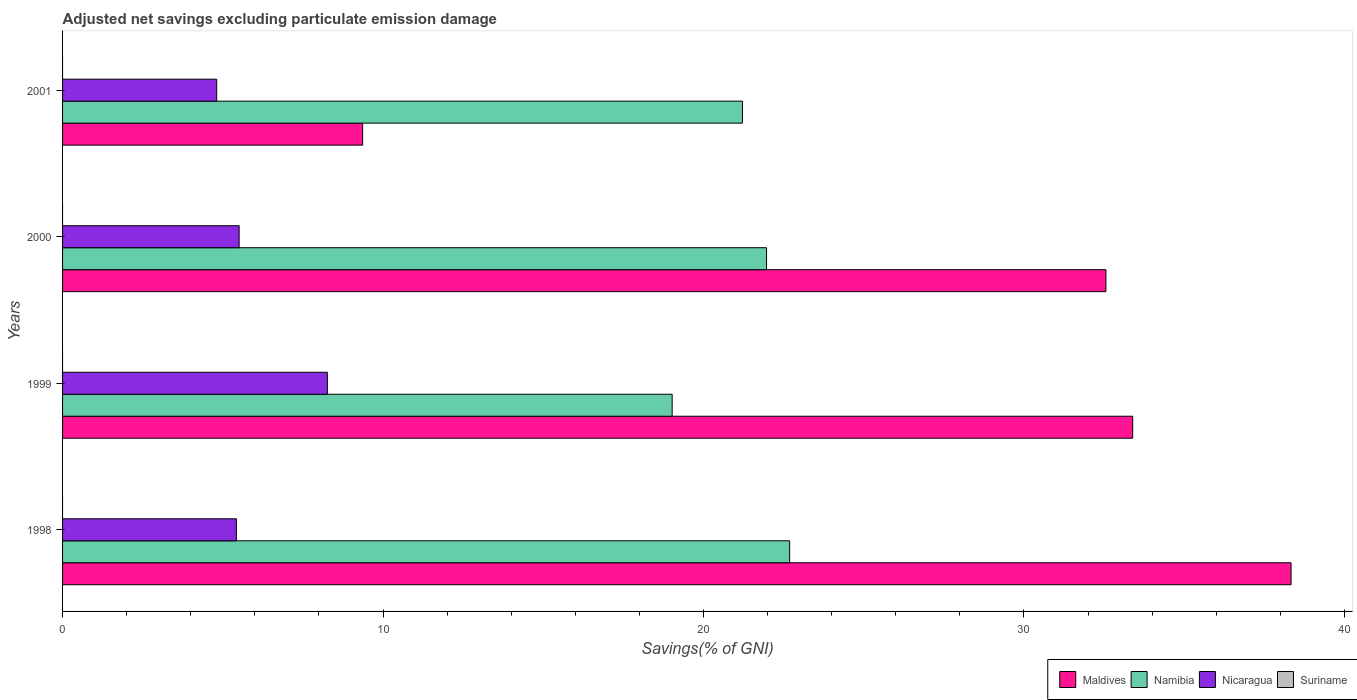How many different coloured bars are there?
Make the answer very short. 3. Are the number of bars per tick equal to the number of legend labels?
Offer a very short reply. No. How many bars are there on the 4th tick from the bottom?
Make the answer very short. 3. In how many cases, is the number of bars for a given year not equal to the number of legend labels?
Your answer should be very brief. 4. What is the adjusted net savings in Namibia in 2000?
Give a very brief answer. 21.97. Across all years, what is the maximum adjusted net savings in Namibia?
Make the answer very short. 22.69. Across all years, what is the minimum adjusted net savings in Maldives?
Provide a short and direct response. 9.36. What is the difference between the adjusted net savings in Namibia in 1999 and that in 2000?
Give a very brief answer. -2.95. What is the difference between the adjusted net savings in Nicaragua in 1998 and the adjusted net savings in Maldives in 1999?
Provide a short and direct response. -27.97. What is the average adjusted net savings in Suriname per year?
Your answer should be compact. 0. In the year 1999, what is the difference between the adjusted net savings in Nicaragua and adjusted net savings in Maldives?
Offer a very short reply. -25.13. In how many years, is the adjusted net savings in Nicaragua greater than 12 %?
Make the answer very short. 0. What is the ratio of the adjusted net savings in Nicaragua in 1998 to that in 1999?
Your response must be concise. 0.66. What is the difference between the highest and the second highest adjusted net savings in Nicaragua?
Your response must be concise. 2.75. What is the difference between the highest and the lowest adjusted net savings in Maldives?
Keep it short and to the point. 28.97. In how many years, is the adjusted net savings in Maldives greater than the average adjusted net savings in Maldives taken over all years?
Your response must be concise. 3. Is it the case that in every year, the sum of the adjusted net savings in Maldives and adjusted net savings in Suriname is greater than the sum of adjusted net savings in Nicaragua and adjusted net savings in Namibia?
Give a very brief answer. No. Is it the case that in every year, the sum of the adjusted net savings in Namibia and adjusted net savings in Suriname is greater than the adjusted net savings in Nicaragua?
Provide a succinct answer. Yes. Does the graph contain any zero values?
Your response must be concise. Yes. Does the graph contain grids?
Offer a very short reply. No. What is the title of the graph?
Offer a terse response. Adjusted net savings excluding particulate emission damage. Does "Israel" appear as one of the legend labels in the graph?
Offer a very short reply. No. What is the label or title of the X-axis?
Ensure brevity in your answer.  Savings(% of GNI). What is the label or title of the Y-axis?
Provide a short and direct response. Years. What is the Savings(% of GNI) in Maldives in 1998?
Offer a very short reply. 38.34. What is the Savings(% of GNI) in Namibia in 1998?
Make the answer very short. 22.69. What is the Savings(% of GNI) in Nicaragua in 1998?
Make the answer very short. 5.42. What is the Savings(% of GNI) in Maldives in 1999?
Provide a short and direct response. 33.4. What is the Savings(% of GNI) in Namibia in 1999?
Offer a terse response. 19.02. What is the Savings(% of GNI) in Nicaragua in 1999?
Provide a short and direct response. 8.26. What is the Savings(% of GNI) of Maldives in 2000?
Your answer should be compact. 32.56. What is the Savings(% of GNI) in Namibia in 2000?
Your response must be concise. 21.97. What is the Savings(% of GNI) in Nicaragua in 2000?
Make the answer very short. 5.51. What is the Savings(% of GNI) in Suriname in 2000?
Keep it short and to the point. 0. What is the Savings(% of GNI) of Maldives in 2001?
Provide a short and direct response. 9.36. What is the Savings(% of GNI) in Namibia in 2001?
Offer a very short reply. 21.22. What is the Savings(% of GNI) in Nicaragua in 2001?
Offer a terse response. 4.81. Across all years, what is the maximum Savings(% of GNI) in Maldives?
Offer a terse response. 38.34. Across all years, what is the maximum Savings(% of GNI) in Namibia?
Provide a succinct answer. 22.69. Across all years, what is the maximum Savings(% of GNI) in Nicaragua?
Provide a succinct answer. 8.26. Across all years, what is the minimum Savings(% of GNI) in Maldives?
Your answer should be very brief. 9.36. Across all years, what is the minimum Savings(% of GNI) in Namibia?
Provide a succinct answer. 19.02. Across all years, what is the minimum Savings(% of GNI) in Nicaragua?
Your answer should be compact. 4.81. What is the total Savings(% of GNI) in Maldives in the graph?
Provide a succinct answer. 113.66. What is the total Savings(% of GNI) in Namibia in the graph?
Keep it short and to the point. 84.9. What is the total Savings(% of GNI) of Nicaragua in the graph?
Your response must be concise. 24.01. What is the difference between the Savings(% of GNI) of Maldives in 1998 and that in 1999?
Your answer should be very brief. 4.94. What is the difference between the Savings(% of GNI) in Namibia in 1998 and that in 1999?
Your response must be concise. 3.67. What is the difference between the Savings(% of GNI) in Nicaragua in 1998 and that in 1999?
Your answer should be very brief. -2.84. What is the difference between the Savings(% of GNI) of Maldives in 1998 and that in 2000?
Offer a terse response. 5.78. What is the difference between the Savings(% of GNI) of Namibia in 1998 and that in 2000?
Make the answer very short. 0.72. What is the difference between the Savings(% of GNI) in Nicaragua in 1998 and that in 2000?
Your response must be concise. -0.09. What is the difference between the Savings(% of GNI) of Maldives in 1998 and that in 2001?
Provide a succinct answer. 28.97. What is the difference between the Savings(% of GNI) in Namibia in 1998 and that in 2001?
Keep it short and to the point. 1.47. What is the difference between the Savings(% of GNI) in Nicaragua in 1998 and that in 2001?
Your answer should be very brief. 0.61. What is the difference between the Savings(% of GNI) of Maldives in 1999 and that in 2000?
Your answer should be compact. 0.84. What is the difference between the Savings(% of GNI) of Namibia in 1999 and that in 2000?
Give a very brief answer. -2.95. What is the difference between the Savings(% of GNI) in Nicaragua in 1999 and that in 2000?
Make the answer very short. 2.75. What is the difference between the Savings(% of GNI) of Maldives in 1999 and that in 2001?
Provide a short and direct response. 24.03. What is the difference between the Savings(% of GNI) in Namibia in 1999 and that in 2001?
Keep it short and to the point. -2.19. What is the difference between the Savings(% of GNI) of Nicaragua in 1999 and that in 2001?
Provide a short and direct response. 3.45. What is the difference between the Savings(% of GNI) in Maldives in 2000 and that in 2001?
Offer a very short reply. 23.19. What is the difference between the Savings(% of GNI) in Namibia in 2000 and that in 2001?
Provide a succinct answer. 0.75. What is the difference between the Savings(% of GNI) in Nicaragua in 2000 and that in 2001?
Your response must be concise. 0.7. What is the difference between the Savings(% of GNI) of Maldives in 1998 and the Savings(% of GNI) of Namibia in 1999?
Ensure brevity in your answer.  19.31. What is the difference between the Savings(% of GNI) in Maldives in 1998 and the Savings(% of GNI) in Nicaragua in 1999?
Make the answer very short. 30.07. What is the difference between the Savings(% of GNI) of Namibia in 1998 and the Savings(% of GNI) of Nicaragua in 1999?
Provide a short and direct response. 14.43. What is the difference between the Savings(% of GNI) in Maldives in 1998 and the Savings(% of GNI) in Namibia in 2000?
Your answer should be compact. 16.37. What is the difference between the Savings(% of GNI) of Maldives in 1998 and the Savings(% of GNI) of Nicaragua in 2000?
Keep it short and to the point. 32.83. What is the difference between the Savings(% of GNI) of Namibia in 1998 and the Savings(% of GNI) of Nicaragua in 2000?
Offer a terse response. 17.18. What is the difference between the Savings(% of GNI) in Maldives in 1998 and the Savings(% of GNI) in Namibia in 2001?
Provide a succinct answer. 17.12. What is the difference between the Savings(% of GNI) in Maldives in 1998 and the Savings(% of GNI) in Nicaragua in 2001?
Offer a terse response. 33.53. What is the difference between the Savings(% of GNI) of Namibia in 1998 and the Savings(% of GNI) of Nicaragua in 2001?
Your answer should be compact. 17.88. What is the difference between the Savings(% of GNI) of Maldives in 1999 and the Savings(% of GNI) of Namibia in 2000?
Provide a succinct answer. 11.43. What is the difference between the Savings(% of GNI) in Maldives in 1999 and the Savings(% of GNI) in Nicaragua in 2000?
Offer a very short reply. 27.89. What is the difference between the Savings(% of GNI) of Namibia in 1999 and the Savings(% of GNI) of Nicaragua in 2000?
Provide a succinct answer. 13.51. What is the difference between the Savings(% of GNI) in Maldives in 1999 and the Savings(% of GNI) in Namibia in 2001?
Your answer should be very brief. 12.18. What is the difference between the Savings(% of GNI) of Maldives in 1999 and the Savings(% of GNI) of Nicaragua in 2001?
Give a very brief answer. 28.59. What is the difference between the Savings(% of GNI) in Namibia in 1999 and the Savings(% of GNI) in Nicaragua in 2001?
Your response must be concise. 14.21. What is the difference between the Savings(% of GNI) in Maldives in 2000 and the Savings(% of GNI) in Namibia in 2001?
Give a very brief answer. 11.34. What is the difference between the Savings(% of GNI) of Maldives in 2000 and the Savings(% of GNI) of Nicaragua in 2001?
Provide a short and direct response. 27.75. What is the difference between the Savings(% of GNI) of Namibia in 2000 and the Savings(% of GNI) of Nicaragua in 2001?
Make the answer very short. 17.16. What is the average Savings(% of GNI) of Maldives per year?
Your answer should be compact. 28.41. What is the average Savings(% of GNI) of Namibia per year?
Provide a succinct answer. 21.22. What is the average Savings(% of GNI) in Nicaragua per year?
Provide a succinct answer. 6. In the year 1998, what is the difference between the Savings(% of GNI) of Maldives and Savings(% of GNI) of Namibia?
Your response must be concise. 15.65. In the year 1998, what is the difference between the Savings(% of GNI) in Maldives and Savings(% of GNI) in Nicaragua?
Give a very brief answer. 32.91. In the year 1998, what is the difference between the Savings(% of GNI) of Namibia and Savings(% of GNI) of Nicaragua?
Ensure brevity in your answer.  17.27. In the year 1999, what is the difference between the Savings(% of GNI) in Maldives and Savings(% of GNI) in Namibia?
Provide a short and direct response. 14.37. In the year 1999, what is the difference between the Savings(% of GNI) in Maldives and Savings(% of GNI) in Nicaragua?
Your response must be concise. 25.13. In the year 1999, what is the difference between the Savings(% of GNI) in Namibia and Savings(% of GNI) in Nicaragua?
Offer a terse response. 10.76. In the year 2000, what is the difference between the Savings(% of GNI) of Maldives and Savings(% of GNI) of Namibia?
Provide a succinct answer. 10.59. In the year 2000, what is the difference between the Savings(% of GNI) in Maldives and Savings(% of GNI) in Nicaragua?
Your answer should be very brief. 27.05. In the year 2000, what is the difference between the Savings(% of GNI) in Namibia and Savings(% of GNI) in Nicaragua?
Make the answer very short. 16.46. In the year 2001, what is the difference between the Savings(% of GNI) in Maldives and Savings(% of GNI) in Namibia?
Make the answer very short. -11.85. In the year 2001, what is the difference between the Savings(% of GNI) in Maldives and Savings(% of GNI) in Nicaragua?
Your answer should be compact. 4.56. In the year 2001, what is the difference between the Savings(% of GNI) of Namibia and Savings(% of GNI) of Nicaragua?
Provide a short and direct response. 16.41. What is the ratio of the Savings(% of GNI) in Maldives in 1998 to that in 1999?
Your answer should be compact. 1.15. What is the ratio of the Savings(% of GNI) of Namibia in 1998 to that in 1999?
Give a very brief answer. 1.19. What is the ratio of the Savings(% of GNI) in Nicaragua in 1998 to that in 1999?
Your answer should be very brief. 0.66. What is the ratio of the Savings(% of GNI) of Maldives in 1998 to that in 2000?
Your answer should be very brief. 1.18. What is the ratio of the Savings(% of GNI) of Namibia in 1998 to that in 2000?
Provide a short and direct response. 1.03. What is the ratio of the Savings(% of GNI) in Nicaragua in 1998 to that in 2000?
Offer a terse response. 0.98. What is the ratio of the Savings(% of GNI) of Maldives in 1998 to that in 2001?
Your response must be concise. 4.09. What is the ratio of the Savings(% of GNI) in Namibia in 1998 to that in 2001?
Your answer should be compact. 1.07. What is the ratio of the Savings(% of GNI) of Nicaragua in 1998 to that in 2001?
Provide a short and direct response. 1.13. What is the ratio of the Savings(% of GNI) of Maldives in 1999 to that in 2000?
Your answer should be compact. 1.03. What is the ratio of the Savings(% of GNI) in Namibia in 1999 to that in 2000?
Keep it short and to the point. 0.87. What is the ratio of the Savings(% of GNI) in Nicaragua in 1999 to that in 2000?
Make the answer very short. 1.5. What is the ratio of the Savings(% of GNI) in Maldives in 1999 to that in 2001?
Ensure brevity in your answer.  3.57. What is the ratio of the Savings(% of GNI) of Namibia in 1999 to that in 2001?
Provide a succinct answer. 0.9. What is the ratio of the Savings(% of GNI) of Nicaragua in 1999 to that in 2001?
Your answer should be compact. 1.72. What is the ratio of the Savings(% of GNI) in Maldives in 2000 to that in 2001?
Provide a succinct answer. 3.48. What is the ratio of the Savings(% of GNI) in Namibia in 2000 to that in 2001?
Offer a terse response. 1.04. What is the ratio of the Savings(% of GNI) in Nicaragua in 2000 to that in 2001?
Give a very brief answer. 1.15. What is the difference between the highest and the second highest Savings(% of GNI) of Maldives?
Provide a succinct answer. 4.94. What is the difference between the highest and the second highest Savings(% of GNI) in Namibia?
Offer a terse response. 0.72. What is the difference between the highest and the second highest Savings(% of GNI) in Nicaragua?
Make the answer very short. 2.75. What is the difference between the highest and the lowest Savings(% of GNI) of Maldives?
Ensure brevity in your answer.  28.97. What is the difference between the highest and the lowest Savings(% of GNI) in Namibia?
Offer a very short reply. 3.67. What is the difference between the highest and the lowest Savings(% of GNI) of Nicaragua?
Ensure brevity in your answer.  3.45. 